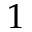<formula> <loc_0><loc_0><loc_500><loc_500>1</formula> 